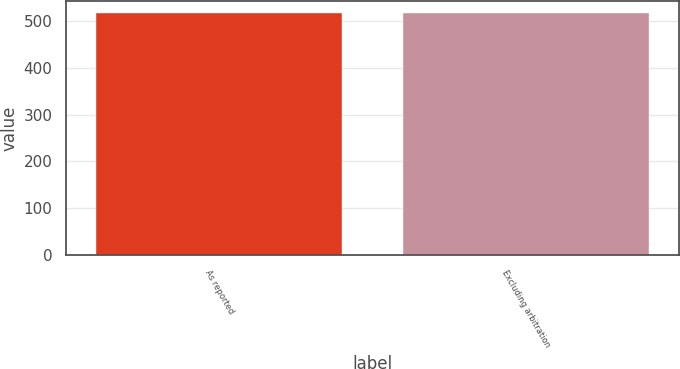Convert chart. <chart><loc_0><loc_0><loc_500><loc_500><bar_chart><fcel>As reported<fcel>Excluding arbitration<nl><fcel>516.4<fcel>516.5<nl></chart> 